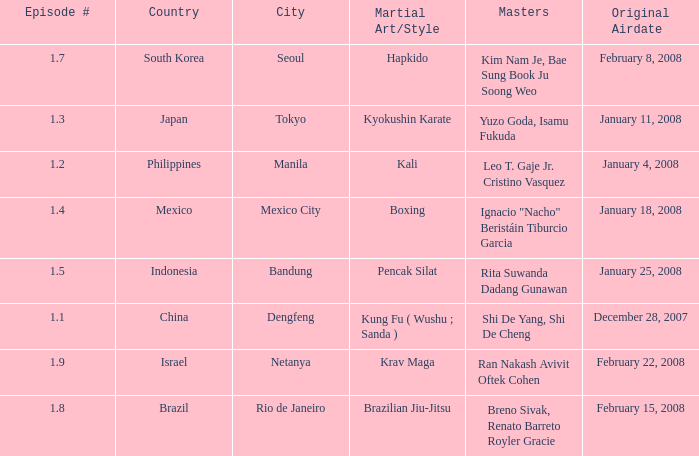Would you mind parsing the complete table? {'header': ['Episode #', 'Country', 'City', 'Martial Art/Style', 'Masters', 'Original Airdate'], 'rows': [['1.7', 'South Korea', 'Seoul', 'Hapkido', 'Kim Nam Je, Bae Sung Book Ju Soong Weo', 'February 8, 2008'], ['1.3', 'Japan', 'Tokyo', 'Kyokushin Karate', 'Yuzo Goda, Isamu Fukuda', 'January 11, 2008'], ['1.2', 'Philippines', 'Manila', 'Kali', 'Leo T. Gaje Jr. Cristino Vasquez', 'January 4, 2008'], ['1.4', 'Mexico', 'Mexico City', 'Boxing', 'Ignacio "Nacho" Beristáin Tiburcio Garcia', 'January 18, 2008'], ['1.5', 'Indonesia', 'Bandung', 'Pencak Silat', 'Rita Suwanda Dadang Gunawan', 'January 25, 2008'], ['1.1', 'China', 'Dengfeng', 'Kung Fu ( Wushu ; Sanda )', 'Shi De Yang, Shi De Cheng', 'December 28, 2007'], ['1.9', 'Israel', 'Netanya', 'Krav Maga', 'Ran Nakash Avivit Oftek Cohen', 'February 22, 2008'], ['1.8', 'Brazil', 'Rio de Janeiro', 'Brazilian Jiu-Jitsu', 'Breno Sivak, Renato Barreto Royler Gracie', 'February 15, 2008']]} When did the episode featuring a master using Brazilian jiu-jitsu air? February 15, 2008. 